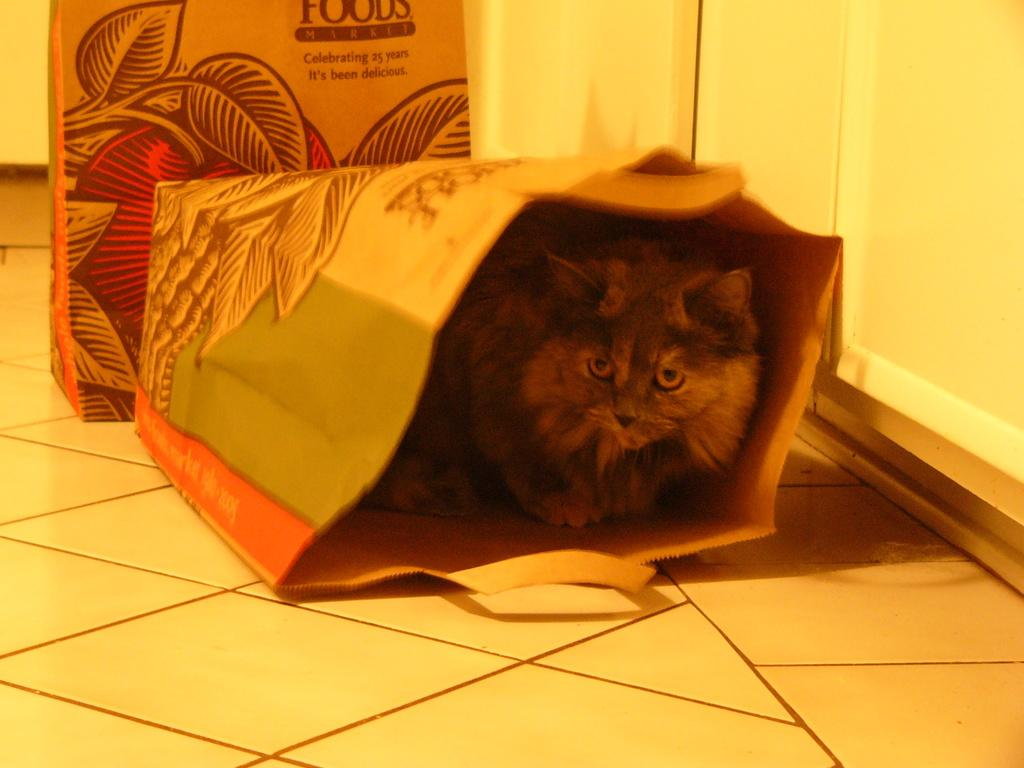What is located in the center of the image? There is a cat in the bag in the center of the image. Can you describe the background of the image? There is a bag and a wall in the background of the image. What type of art can be seen hanging on the wall in the image? There is no art visible on the wall in the image; only the wall itself is mentioned. Is there a town or bridge present in the image? No, there is no town or bridge present in the image. 